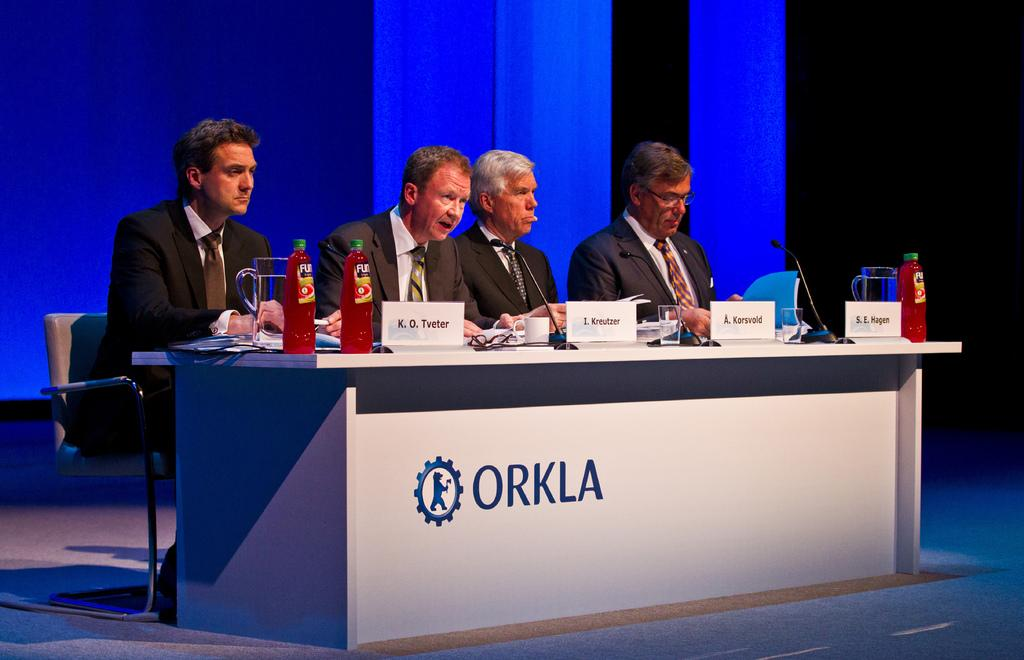What is present on the table in the image? There are glasses, bottles, name plates, and microphones on the table in the image. How many people are seated in the image? There are 4 people seated in the image. What are the people wearing? The people are wearing suits. Are there any worms crawling on the table in the image? No, there are no worms present in the image. 